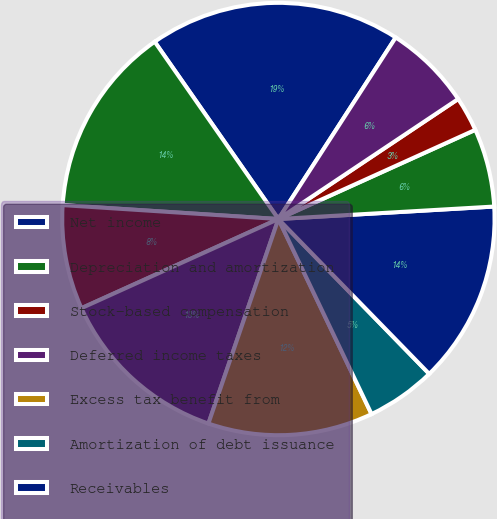Convert chart to OTSL. <chart><loc_0><loc_0><loc_500><loc_500><pie_chart><fcel>Net income<fcel>Depreciation and amortization<fcel>Stock-based compensation<fcel>Deferred income taxes<fcel>Excess tax benefit from<fcel>Amortization of debt issuance<fcel>Receivables<fcel>Inventory<fcel>Prepaid expenses and other<fcel>Accounts payable<nl><fcel>18.83%<fcel>14.28%<fcel>7.79%<fcel>12.99%<fcel>12.34%<fcel>5.2%<fcel>13.63%<fcel>5.85%<fcel>2.6%<fcel>6.5%<nl></chart> 